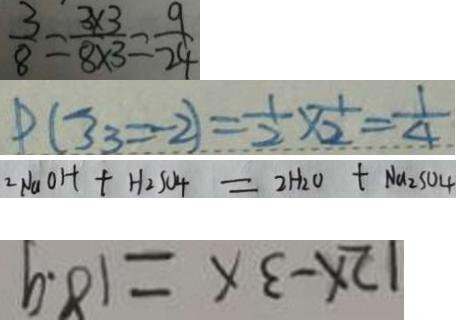Convert formula to latex. <formula><loc_0><loc_0><loc_500><loc_500>\frac { 3 } { 8 } = \frac { 3 \times 3 } { 8 \times 3 } = \frac { 9 } { 2 4 } 
 P ( 3 3 = 2 ) = \frac { 1 } { 2 } \times \frac { 1 } { 2 } = \frac { 1 } { 4 } 
 2 N a O H + H _ { 2 } S O _ { 4 } = 2 H _ { 2 } O + N a _ { 2 } S O _ { 4 } 
 1 2 x - 3 a = 1 8 . 9</formula> 